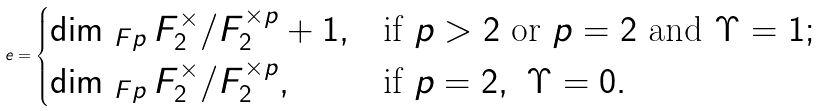<formula> <loc_0><loc_0><loc_500><loc_500>e = \begin{cases} \dim _ { \ F p } F _ { 2 } ^ { \times } / F _ { 2 } ^ { \times p } + 1 , & \text {if } p > 2 \text { or } p = 2 \text { and } \Upsilon = 1 ; \\ \dim _ { \ F p } F _ { 2 } ^ { \times } / F _ { 2 } ^ { \times p } , & \text {if } p = 2 , \ \Upsilon = 0 . \\ \end{cases}</formula> 